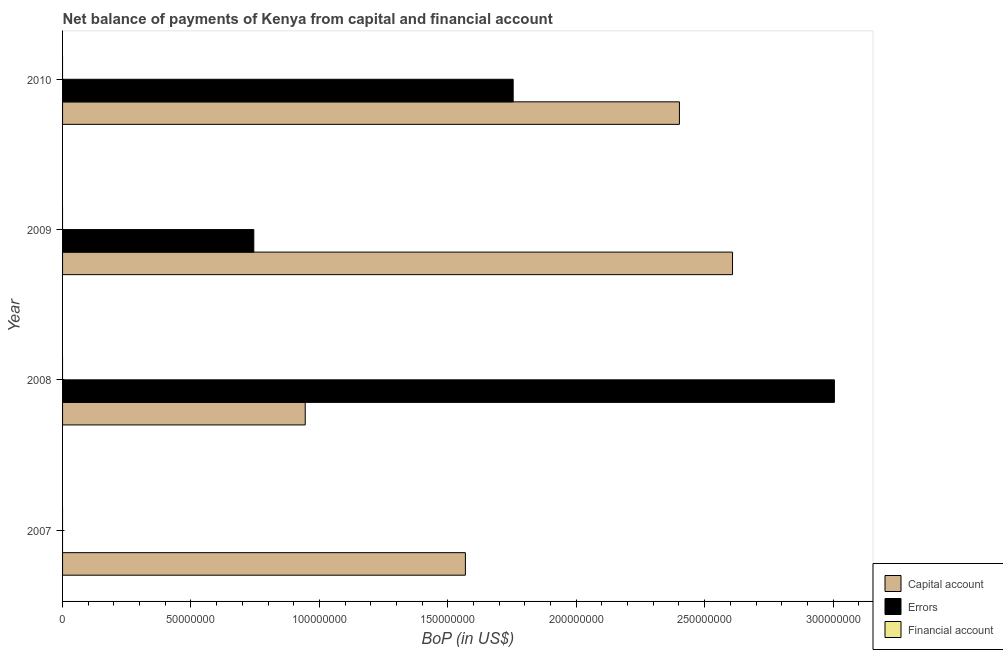How many bars are there on the 1st tick from the top?
Your answer should be very brief. 2. What is the label of the 3rd group of bars from the top?
Your response must be concise. 2008. In how many cases, is the number of bars for a given year not equal to the number of legend labels?
Provide a succinct answer. 4. What is the amount of errors in 2007?
Give a very brief answer. 0. Across all years, what is the maximum amount of net capital account?
Give a very brief answer. 2.61e+08. Across all years, what is the minimum amount of financial account?
Provide a succinct answer. 0. In which year was the amount of net capital account maximum?
Provide a succinct answer. 2009. What is the total amount of financial account in the graph?
Your answer should be very brief. 0. What is the difference between the amount of net capital account in 2007 and that in 2010?
Offer a very short reply. -8.33e+07. What is the difference between the amount of errors in 2010 and the amount of financial account in 2008?
Your response must be concise. 1.75e+08. What is the average amount of errors per year?
Your answer should be compact. 1.38e+08. In the year 2010, what is the difference between the amount of errors and amount of net capital account?
Provide a short and direct response. -6.47e+07. In how many years, is the amount of financial account greater than 100000000 US$?
Your answer should be compact. 0. What is the ratio of the amount of net capital account in 2007 to that in 2010?
Ensure brevity in your answer.  0.65. What is the difference between the highest and the second highest amount of net capital account?
Offer a very short reply. 2.07e+07. What is the difference between the highest and the lowest amount of net capital account?
Offer a very short reply. 1.66e+08. Is the sum of the amount of net capital account in 2007 and 2008 greater than the maximum amount of errors across all years?
Your answer should be very brief. No. Does the graph contain any zero values?
Keep it short and to the point. Yes. What is the title of the graph?
Give a very brief answer. Net balance of payments of Kenya from capital and financial account. Does "Ages 65 and above" appear as one of the legend labels in the graph?
Your answer should be very brief. No. What is the label or title of the X-axis?
Your answer should be very brief. BoP (in US$). What is the label or title of the Y-axis?
Keep it short and to the point. Year. What is the BoP (in US$) in Capital account in 2007?
Your answer should be compact. 1.57e+08. What is the BoP (in US$) of Capital account in 2008?
Provide a succinct answer. 9.45e+07. What is the BoP (in US$) of Errors in 2008?
Offer a very short reply. 3.01e+08. What is the BoP (in US$) in Capital account in 2009?
Ensure brevity in your answer.  2.61e+08. What is the BoP (in US$) of Errors in 2009?
Your answer should be compact. 7.45e+07. What is the BoP (in US$) in Capital account in 2010?
Offer a terse response. 2.40e+08. What is the BoP (in US$) in Errors in 2010?
Provide a short and direct response. 1.75e+08. What is the BoP (in US$) of Financial account in 2010?
Give a very brief answer. 0. Across all years, what is the maximum BoP (in US$) of Capital account?
Give a very brief answer. 2.61e+08. Across all years, what is the maximum BoP (in US$) of Errors?
Give a very brief answer. 3.01e+08. Across all years, what is the minimum BoP (in US$) in Capital account?
Your answer should be very brief. 9.45e+07. What is the total BoP (in US$) in Capital account in the graph?
Your answer should be compact. 7.52e+08. What is the total BoP (in US$) of Errors in the graph?
Your answer should be very brief. 5.50e+08. What is the total BoP (in US$) in Financial account in the graph?
Keep it short and to the point. 0. What is the difference between the BoP (in US$) in Capital account in 2007 and that in 2008?
Make the answer very short. 6.24e+07. What is the difference between the BoP (in US$) of Capital account in 2007 and that in 2009?
Ensure brevity in your answer.  -1.04e+08. What is the difference between the BoP (in US$) in Capital account in 2007 and that in 2010?
Your answer should be compact. -8.33e+07. What is the difference between the BoP (in US$) of Capital account in 2008 and that in 2009?
Your answer should be compact. -1.66e+08. What is the difference between the BoP (in US$) in Errors in 2008 and that in 2009?
Your answer should be compact. 2.26e+08. What is the difference between the BoP (in US$) in Capital account in 2008 and that in 2010?
Give a very brief answer. -1.46e+08. What is the difference between the BoP (in US$) in Errors in 2008 and that in 2010?
Make the answer very short. 1.25e+08. What is the difference between the BoP (in US$) of Capital account in 2009 and that in 2010?
Your response must be concise. 2.07e+07. What is the difference between the BoP (in US$) in Errors in 2009 and that in 2010?
Offer a terse response. -1.01e+08. What is the difference between the BoP (in US$) in Capital account in 2007 and the BoP (in US$) in Errors in 2008?
Your response must be concise. -1.44e+08. What is the difference between the BoP (in US$) in Capital account in 2007 and the BoP (in US$) in Errors in 2009?
Your response must be concise. 8.24e+07. What is the difference between the BoP (in US$) in Capital account in 2007 and the BoP (in US$) in Errors in 2010?
Ensure brevity in your answer.  -1.86e+07. What is the difference between the BoP (in US$) in Capital account in 2008 and the BoP (in US$) in Errors in 2009?
Your answer should be very brief. 2.00e+07. What is the difference between the BoP (in US$) in Capital account in 2008 and the BoP (in US$) in Errors in 2010?
Keep it short and to the point. -8.10e+07. What is the difference between the BoP (in US$) in Capital account in 2009 and the BoP (in US$) in Errors in 2010?
Ensure brevity in your answer.  8.54e+07. What is the average BoP (in US$) of Capital account per year?
Your answer should be very brief. 1.88e+08. What is the average BoP (in US$) of Errors per year?
Give a very brief answer. 1.38e+08. What is the average BoP (in US$) in Financial account per year?
Give a very brief answer. 0. In the year 2008, what is the difference between the BoP (in US$) in Capital account and BoP (in US$) in Errors?
Offer a very short reply. -2.06e+08. In the year 2009, what is the difference between the BoP (in US$) of Capital account and BoP (in US$) of Errors?
Ensure brevity in your answer.  1.86e+08. In the year 2010, what is the difference between the BoP (in US$) in Capital account and BoP (in US$) in Errors?
Ensure brevity in your answer.  6.47e+07. What is the ratio of the BoP (in US$) of Capital account in 2007 to that in 2008?
Provide a short and direct response. 1.66. What is the ratio of the BoP (in US$) in Capital account in 2007 to that in 2009?
Your answer should be compact. 0.6. What is the ratio of the BoP (in US$) in Capital account in 2007 to that in 2010?
Your answer should be very brief. 0.65. What is the ratio of the BoP (in US$) in Capital account in 2008 to that in 2009?
Keep it short and to the point. 0.36. What is the ratio of the BoP (in US$) in Errors in 2008 to that in 2009?
Give a very brief answer. 4.04. What is the ratio of the BoP (in US$) of Capital account in 2008 to that in 2010?
Ensure brevity in your answer.  0.39. What is the ratio of the BoP (in US$) of Errors in 2008 to that in 2010?
Make the answer very short. 1.71. What is the ratio of the BoP (in US$) of Capital account in 2009 to that in 2010?
Give a very brief answer. 1.09. What is the ratio of the BoP (in US$) of Errors in 2009 to that in 2010?
Offer a very short reply. 0.42. What is the difference between the highest and the second highest BoP (in US$) in Capital account?
Offer a very short reply. 2.07e+07. What is the difference between the highest and the second highest BoP (in US$) of Errors?
Keep it short and to the point. 1.25e+08. What is the difference between the highest and the lowest BoP (in US$) of Capital account?
Your response must be concise. 1.66e+08. What is the difference between the highest and the lowest BoP (in US$) of Errors?
Offer a very short reply. 3.01e+08. 